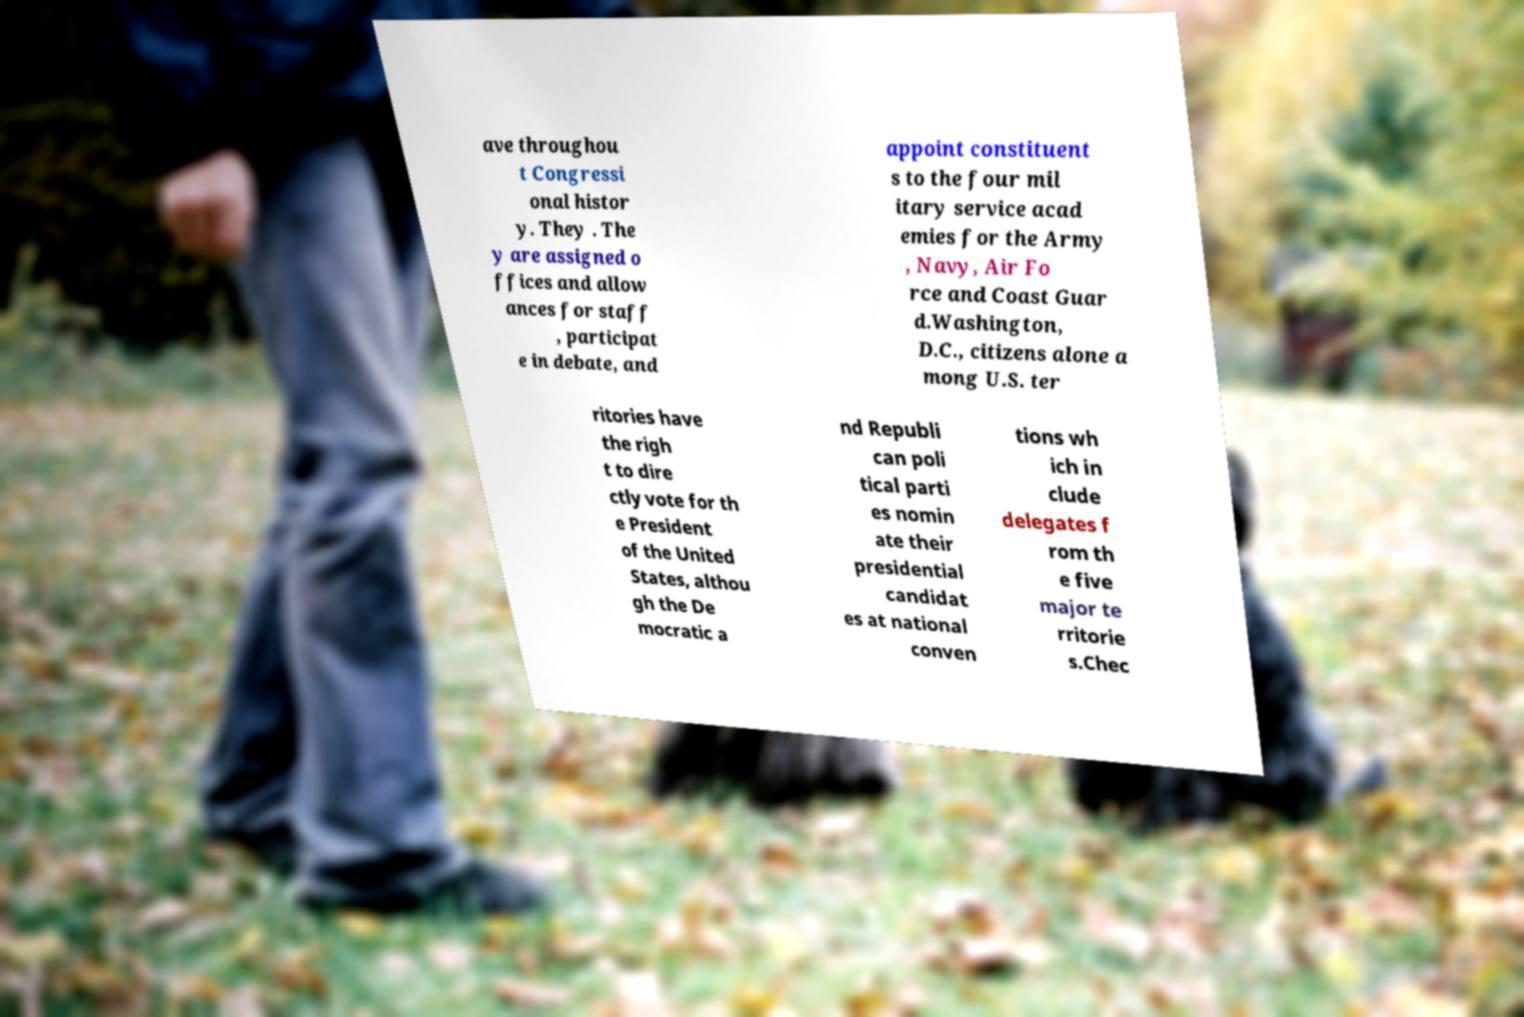There's text embedded in this image that I need extracted. Can you transcribe it verbatim? ave throughou t Congressi onal histor y. They . The y are assigned o ffices and allow ances for staff , participat e in debate, and appoint constituent s to the four mil itary service acad emies for the Army , Navy, Air Fo rce and Coast Guar d.Washington, D.C., citizens alone a mong U.S. ter ritories have the righ t to dire ctly vote for th e President of the United States, althou gh the De mocratic a nd Republi can poli tical parti es nomin ate their presidential candidat es at national conven tions wh ich in clude delegates f rom th e five major te rritorie s.Chec 